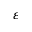Convert formula to latex. <formula><loc_0><loc_0><loc_500><loc_500>\varepsilon</formula> 